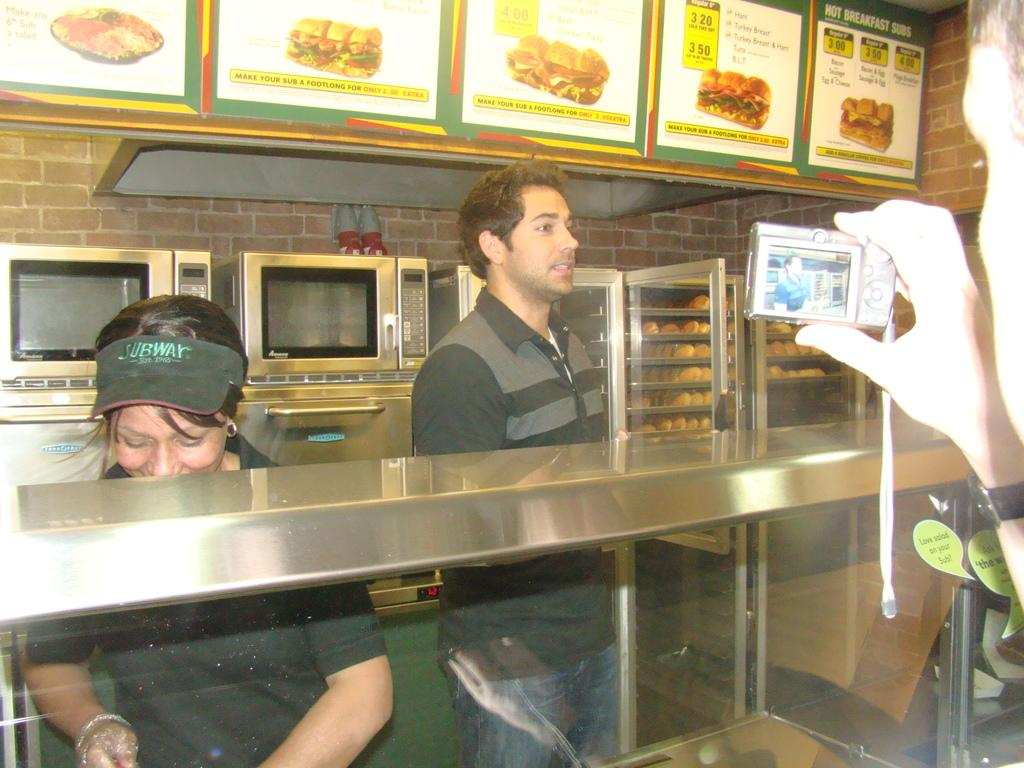Provide a one-sentence caption for the provided image. Subway workers stand behind a counter as their photo is taken. 